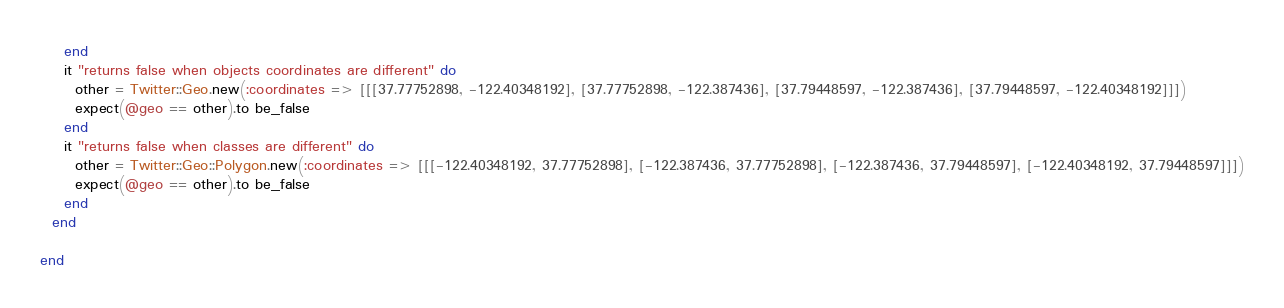Convert code to text. <code><loc_0><loc_0><loc_500><loc_500><_Ruby_>    end
    it "returns false when objects coordinates are different" do
      other = Twitter::Geo.new(:coordinates => [[[37.77752898, -122.40348192], [37.77752898, -122.387436], [37.79448597, -122.387436], [37.79448597, -122.40348192]]])
      expect(@geo == other).to be_false
    end
    it "returns false when classes are different" do
      other = Twitter::Geo::Polygon.new(:coordinates => [[[-122.40348192, 37.77752898], [-122.387436, 37.77752898], [-122.387436, 37.79448597], [-122.40348192, 37.79448597]]])
      expect(@geo == other).to be_false
    end
  end

end
</code> 